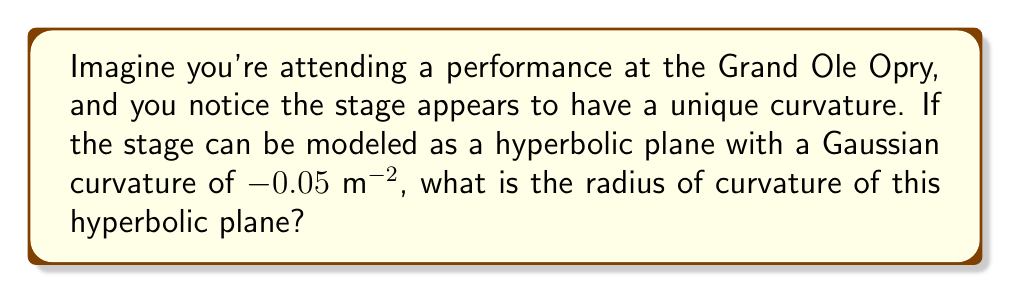Solve this math problem. Let's approach this step-by-step:

1) In hyperbolic geometry, the Gaussian curvature ($K$) is constant and negative. It's given as:

   $$K = -\frac{1}{R^2}$$

   where $R$ is the radius of curvature.

2) We're given that $K = -0.05$ $m^{-2}$. Let's substitute this into our equation:

   $$-0.05 = -\frac{1}{R^2}$$

3) To solve for $R$, we first multiply both sides by $-1$:

   $$0.05 = \frac{1}{R^2}$$

4) Now, we take the reciprocal of both sides:

   $$\frac{1}{0.05} = R^2$$

5) Simplify:

   $$20 = R^2$$

6) Finally, take the square root of both sides:

   $$R = \sqrt{20} = 2\sqrt{5}$$

Therefore, the radius of curvature of the hyperbolic plane modeling the Grand Ole Opry stage is $2\sqrt{5}$ meters.
Answer: $2\sqrt{5}$ m 